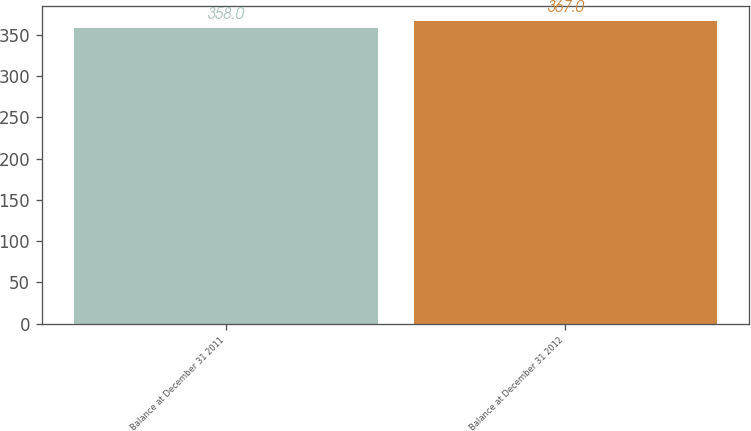Convert chart. <chart><loc_0><loc_0><loc_500><loc_500><bar_chart><fcel>Balance at December 31 2011<fcel>Balance at December 31 2012<nl><fcel>358<fcel>367<nl></chart> 